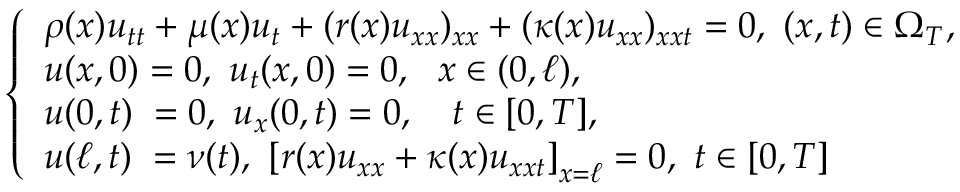<formula> <loc_0><loc_0><loc_500><loc_500>\begin{array} { r } { \left \{ \begin{array} { l c } { \rho ( x ) u _ { t t } + \mu ( x ) u _ { t } + ( r ( x ) u _ { x x } ) _ { x x } + ( \kappa ( x ) u _ { x x } ) _ { x x t } = 0 , ( x , t ) \in \Omega _ { T } , } \\ { u ( x , 0 ) = 0 , u _ { t } ( x , 0 ) = 0 , x \in ( 0 , \ell ) , } \\ { u ( 0 , t ) \, = 0 , u _ { x } ( 0 , t ) = 0 , \ t \in [ 0 , T ] , } \\ { u ( \ell , t ) \, = \nu ( t ) , \left [ r ( x ) u _ { x x } + \kappa ( x ) u _ { x x t } \right ] _ { x = \ell } = 0 , t \in [ 0 , T ] } \end{array} } \end{array}</formula> 